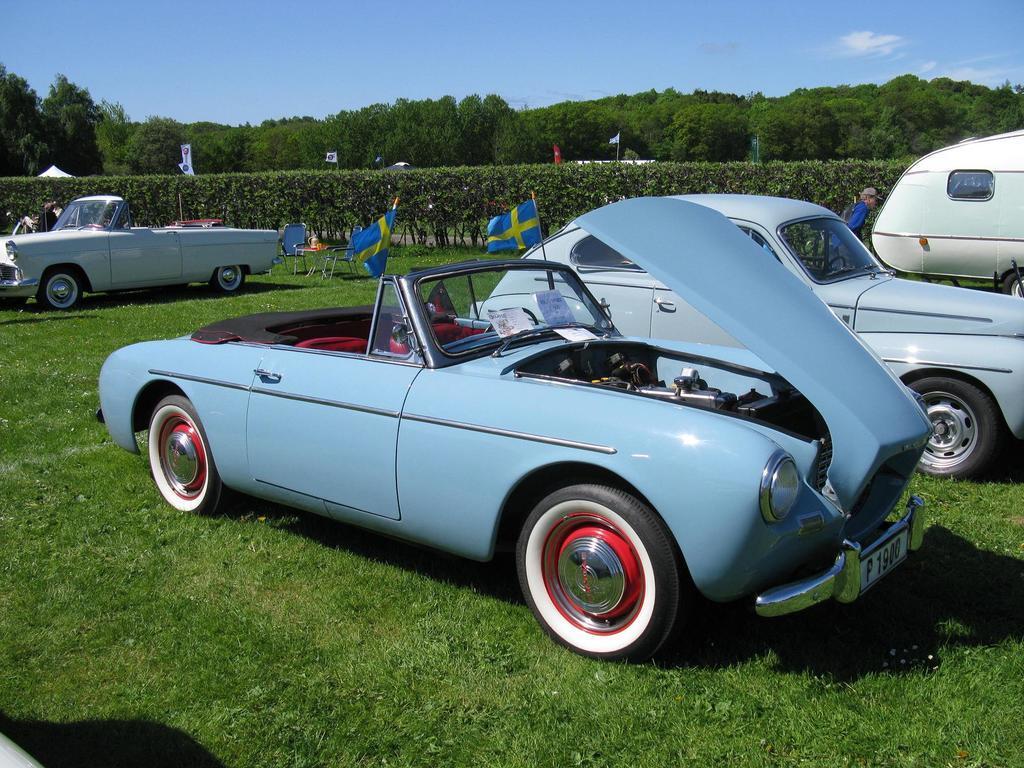Describe this image in one or two sentences. In this image there are a few cars parked on the grass surface, beside the cars there are tables, chairs, flags and few people. On the tables there are some objects, behind them there are bushes, flags, tents and trees. At the top of the image there are clouds in the sky. 